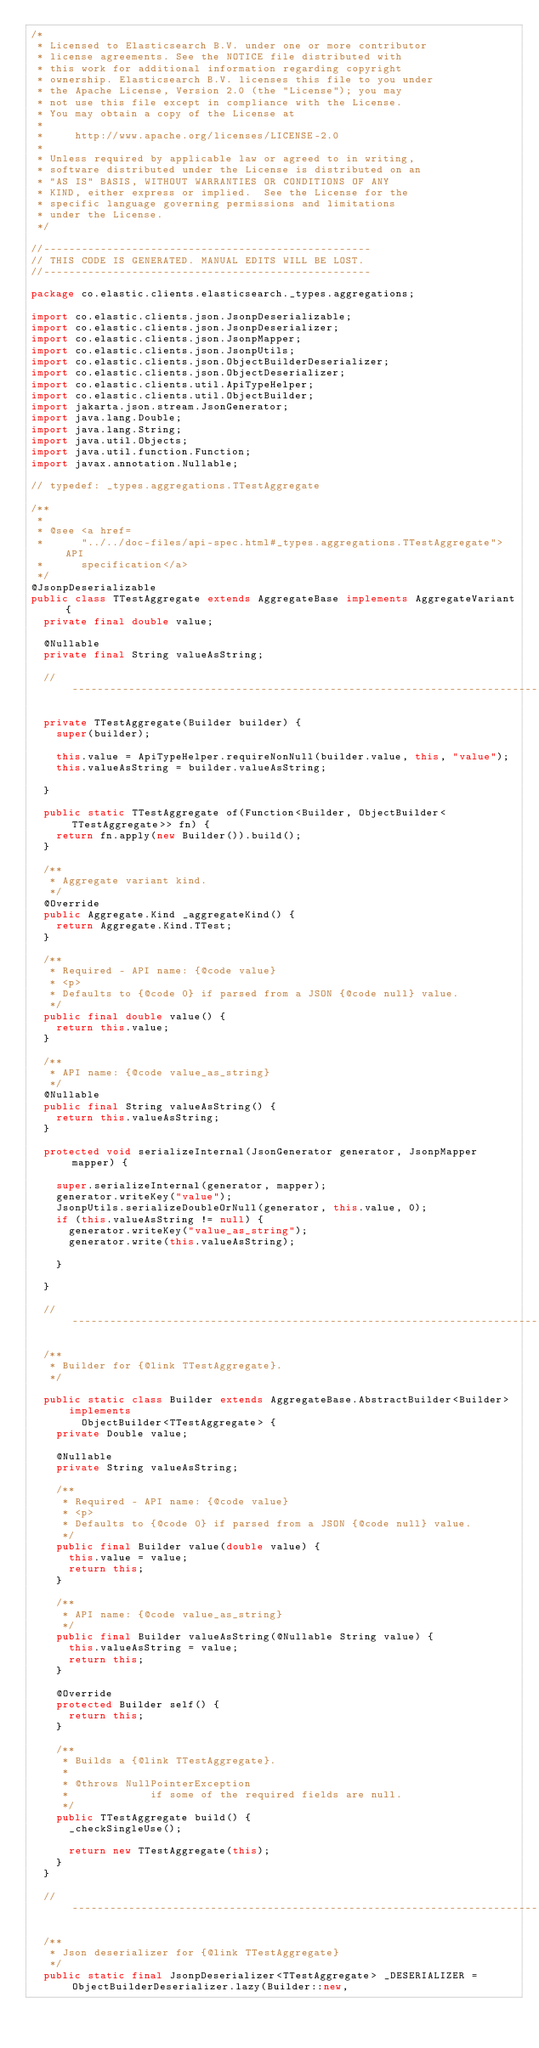Convert code to text. <code><loc_0><loc_0><loc_500><loc_500><_Java_>/*
 * Licensed to Elasticsearch B.V. under one or more contributor
 * license agreements. See the NOTICE file distributed with
 * this work for additional information regarding copyright
 * ownership. Elasticsearch B.V. licenses this file to you under
 * the Apache License, Version 2.0 (the "License"); you may
 * not use this file except in compliance with the License.
 * You may obtain a copy of the License at
 *
 *     http://www.apache.org/licenses/LICENSE-2.0
 *
 * Unless required by applicable law or agreed to in writing,
 * software distributed under the License is distributed on an
 * "AS IS" BASIS, WITHOUT WARRANTIES OR CONDITIONS OF ANY
 * KIND, either express or implied.  See the License for the
 * specific language governing permissions and limitations
 * under the License.
 */

//----------------------------------------------------
// THIS CODE IS GENERATED. MANUAL EDITS WILL BE LOST.
//----------------------------------------------------

package co.elastic.clients.elasticsearch._types.aggregations;

import co.elastic.clients.json.JsonpDeserializable;
import co.elastic.clients.json.JsonpDeserializer;
import co.elastic.clients.json.JsonpMapper;
import co.elastic.clients.json.JsonpUtils;
import co.elastic.clients.json.ObjectBuilderDeserializer;
import co.elastic.clients.json.ObjectDeserializer;
import co.elastic.clients.util.ApiTypeHelper;
import co.elastic.clients.util.ObjectBuilder;
import jakarta.json.stream.JsonGenerator;
import java.lang.Double;
import java.lang.String;
import java.util.Objects;
import java.util.function.Function;
import javax.annotation.Nullable;

// typedef: _types.aggregations.TTestAggregate

/**
 *
 * @see <a href=
 *      "../../doc-files/api-spec.html#_types.aggregations.TTestAggregate">API
 *      specification</a>
 */
@JsonpDeserializable
public class TTestAggregate extends AggregateBase implements AggregateVariant {
	private final double value;

	@Nullable
	private final String valueAsString;

	// ---------------------------------------------------------------------------------------------

	private TTestAggregate(Builder builder) {
		super(builder);

		this.value = ApiTypeHelper.requireNonNull(builder.value, this, "value");
		this.valueAsString = builder.valueAsString;

	}

	public static TTestAggregate of(Function<Builder, ObjectBuilder<TTestAggregate>> fn) {
		return fn.apply(new Builder()).build();
	}

	/**
	 * Aggregate variant kind.
	 */
	@Override
	public Aggregate.Kind _aggregateKind() {
		return Aggregate.Kind.TTest;
	}

	/**
	 * Required - API name: {@code value}
	 * <p>
	 * Defaults to {@code 0} if parsed from a JSON {@code null} value.
	 */
	public final double value() {
		return this.value;
	}

	/**
	 * API name: {@code value_as_string}
	 */
	@Nullable
	public final String valueAsString() {
		return this.valueAsString;
	}

	protected void serializeInternal(JsonGenerator generator, JsonpMapper mapper) {

		super.serializeInternal(generator, mapper);
		generator.writeKey("value");
		JsonpUtils.serializeDoubleOrNull(generator, this.value, 0);
		if (this.valueAsString != null) {
			generator.writeKey("value_as_string");
			generator.write(this.valueAsString);

		}

	}

	// ---------------------------------------------------------------------------------------------

	/**
	 * Builder for {@link TTestAggregate}.
	 */

	public static class Builder extends AggregateBase.AbstractBuilder<Builder>
			implements
				ObjectBuilder<TTestAggregate> {
		private Double value;

		@Nullable
		private String valueAsString;

		/**
		 * Required - API name: {@code value}
		 * <p>
		 * Defaults to {@code 0} if parsed from a JSON {@code null} value.
		 */
		public final Builder value(double value) {
			this.value = value;
			return this;
		}

		/**
		 * API name: {@code value_as_string}
		 */
		public final Builder valueAsString(@Nullable String value) {
			this.valueAsString = value;
			return this;
		}

		@Override
		protected Builder self() {
			return this;
		}

		/**
		 * Builds a {@link TTestAggregate}.
		 *
		 * @throws NullPointerException
		 *             if some of the required fields are null.
		 */
		public TTestAggregate build() {
			_checkSingleUse();

			return new TTestAggregate(this);
		}
	}

	// ---------------------------------------------------------------------------------------------

	/**
	 * Json deserializer for {@link TTestAggregate}
	 */
	public static final JsonpDeserializer<TTestAggregate> _DESERIALIZER = ObjectBuilderDeserializer.lazy(Builder::new,</code> 